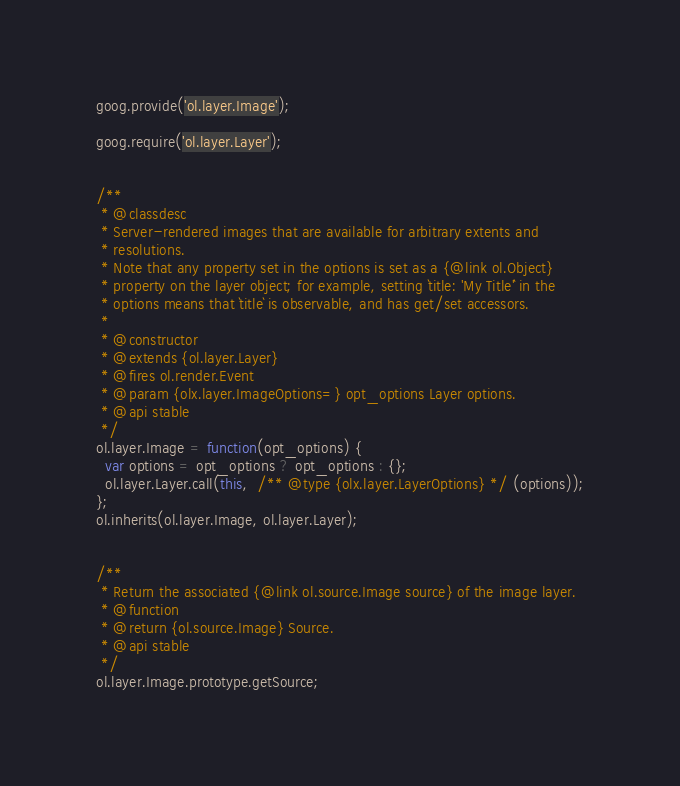<code> <loc_0><loc_0><loc_500><loc_500><_JavaScript_>goog.provide('ol.layer.Image');

goog.require('ol.layer.Layer');


/**
 * @classdesc
 * Server-rendered images that are available for arbitrary extents and
 * resolutions.
 * Note that any property set in the options is set as a {@link ol.Object}
 * property on the layer object; for example, setting `title: 'My Title'` in the
 * options means that `title` is observable, and has get/set accessors.
 *
 * @constructor
 * @extends {ol.layer.Layer}
 * @fires ol.render.Event
 * @param {olx.layer.ImageOptions=} opt_options Layer options.
 * @api stable
 */
ol.layer.Image = function(opt_options) {
  var options = opt_options ? opt_options : {};
  ol.layer.Layer.call(this,  /** @type {olx.layer.LayerOptions} */ (options));
};
ol.inherits(ol.layer.Image, ol.layer.Layer);


/**
 * Return the associated {@link ol.source.Image source} of the image layer.
 * @function
 * @return {ol.source.Image} Source.
 * @api stable
 */
ol.layer.Image.prototype.getSource;
</code> 